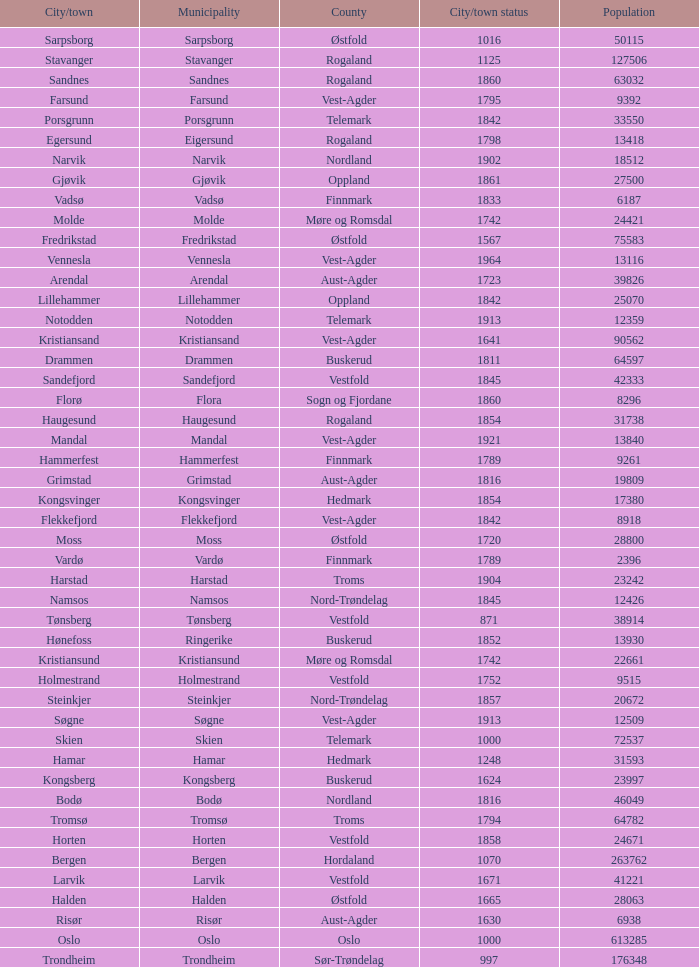In which county is the city/town of Halden located? Østfold. 